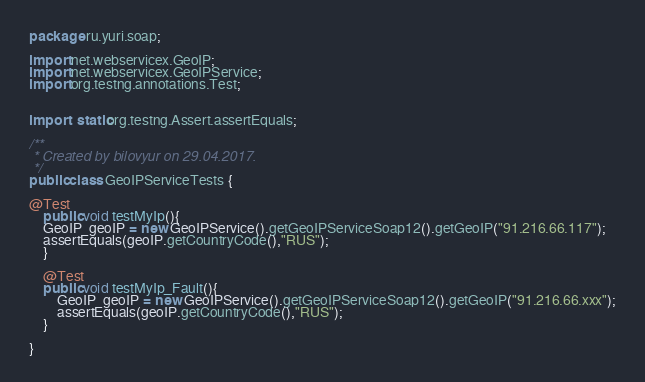Convert code to text. <code><loc_0><loc_0><loc_500><loc_500><_Java_>package ru.yuri.soap;

import net.webservicex.GeoIP;
import net.webservicex.GeoIPService;
import org.testng.annotations.Test;


import static org.testng.Assert.assertEquals;

/**
 * Created by bilovyur on 29.04.2017.
 */
public class GeoIPServiceTests {

@Test
    public void testMyIp(){
    GeoIP  geoIP = new GeoIPService().getGeoIPServiceSoap12().getGeoIP("91.216.66.117");
    assertEquals(geoIP.getCountryCode(),"RUS");
    }

    @Test
    public void testMyIp_Fault(){
        GeoIP  geoIP = new GeoIPService().getGeoIPServiceSoap12().getGeoIP("91.216.66.xxx");
        assertEquals(geoIP.getCountryCode(),"RUS");
    }

}
</code> 